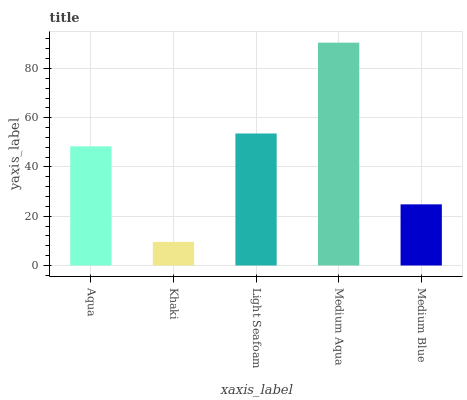Is Khaki the minimum?
Answer yes or no. Yes. Is Medium Aqua the maximum?
Answer yes or no. Yes. Is Light Seafoam the minimum?
Answer yes or no. No. Is Light Seafoam the maximum?
Answer yes or no. No. Is Light Seafoam greater than Khaki?
Answer yes or no. Yes. Is Khaki less than Light Seafoam?
Answer yes or no. Yes. Is Khaki greater than Light Seafoam?
Answer yes or no. No. Is Light Seafoam less than Khaki?
Answer yes or no. No. Is Aqua the high median?
Answer yes or no. Yes. Is Aqua the low median?
Answer yes or no. Yes. Is Khaki the high median?
Answer yes or no. No. Is Medium Blue the low median?
Answer yes or no. No. 